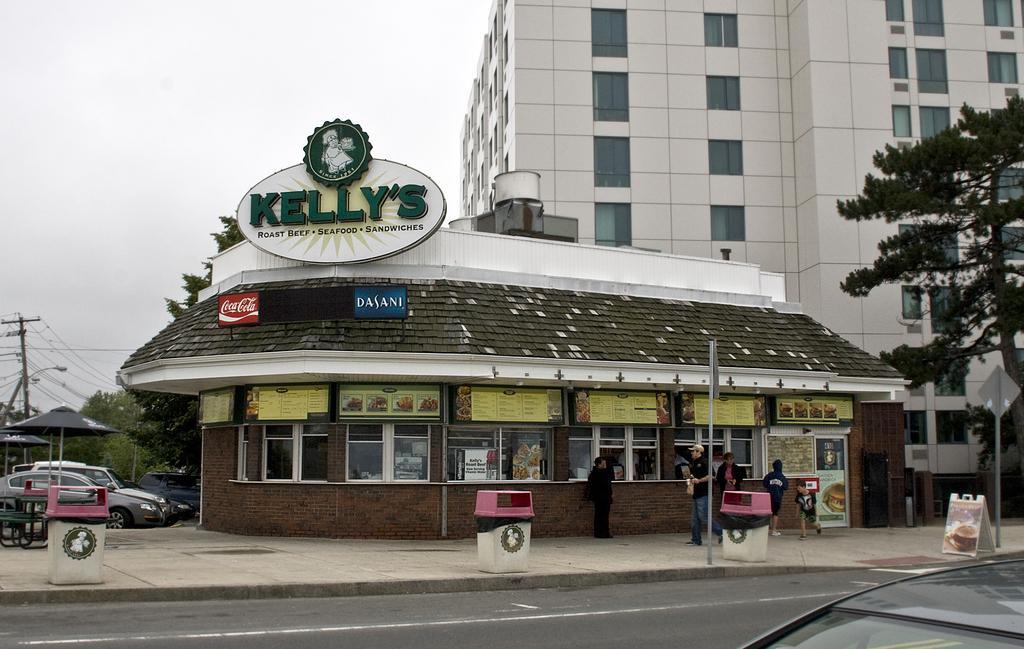Can you describe this image briefly? In this image, we can see a building and at the left side there are some cars and there is a tent, there are some trees, at the top there is a sky. 